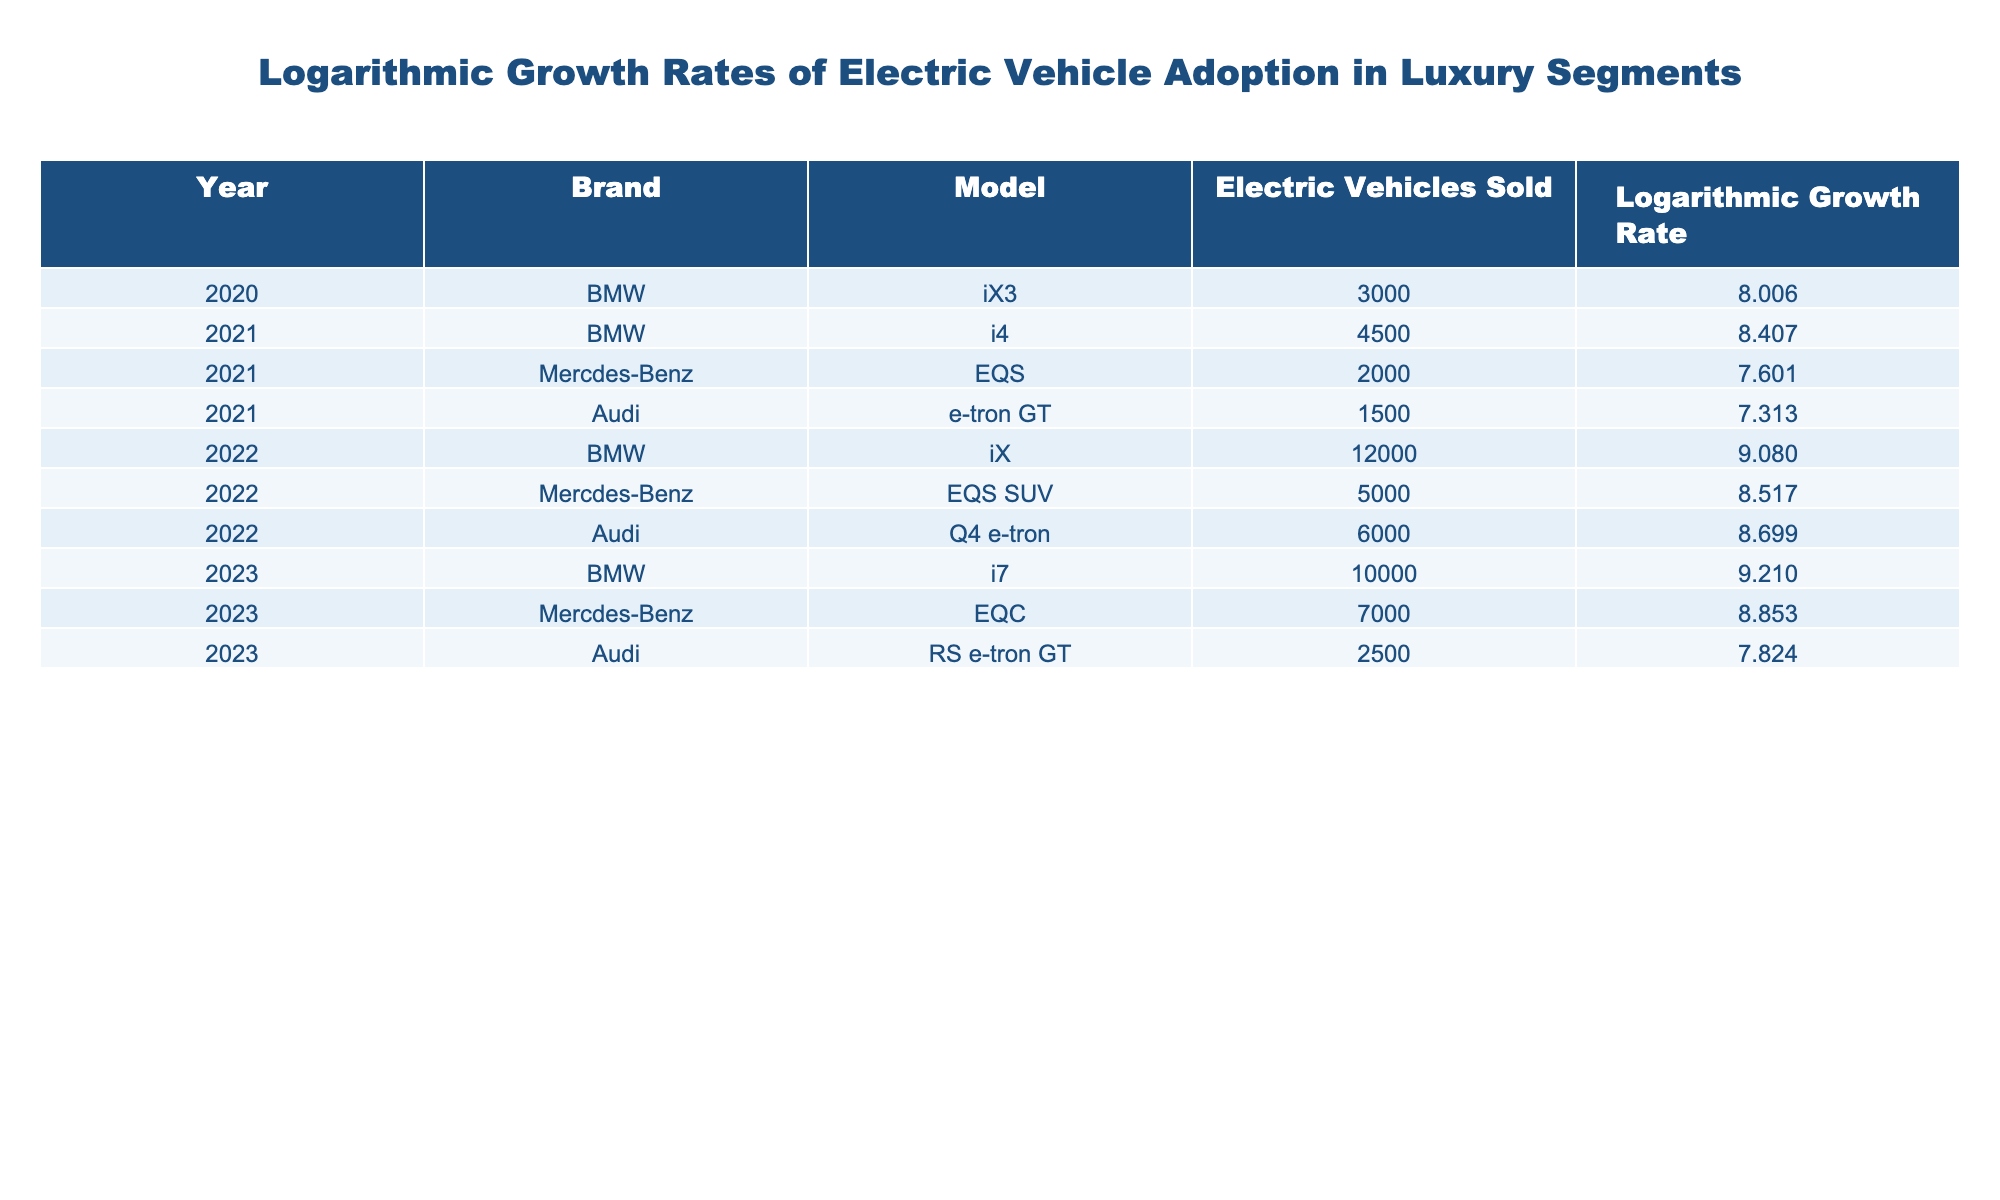What was the highest logarithmic growth rate for BMW electric vehicles in the years provided? The table shows logarithmic growth rates for each model of BMW electric vehicles. By comparing the logarithmic growth rates for the years listed (8.006 for iX3 in 2020, 8.407 for i4 in 2021, 9.080 for iX in 2022, and 9.210 for i7 in 2023), the highest rate is 9.210 for the i7 in 2023.
Answer: 9.210 Which electric vehicle model had the lowest logarithmic growth rate in 2021? The table provides growth rates for electric vehicles sold in 2021. Comparing the growth rates of the listed models (7.601 for EQS, 7.313 for e-tron GT), the lowest growth rate in that year is 7.313 for the Audi e-tron GT.
Answer: 7.313 How many electric vehicles did BMW sell in total across the years listed? To find the total number of electric vehicles sold by BMW, we add the sales figures for each model: 3000 (iX3) + 4500 (i4) + 12000 (iX) + 10000 (i7) = 3000 + 4500 + 12000 + 10000 = 29500.
Answer: 29500 Is it true that Mercedes-Benz sold more electric vehicles than Audi in 2022? In the year 2022, Mercedes-Benz sold 5000 (EQS SUV) while Audi sold 6000 (Q4 e-tron). Therefore, the statement is false, as Audi sold more vehicles than Mercedes-Benz in 2022.
Answer: No What was the percentage increase in electric vehicles sold by BMW from 2021 to 2022? In 2021, BMW sold 4500 vehicles (i4) and in 2022, it sold 12000 vehicles (iX). The increase is 12000 - 4500 = 7500. The percentage increase is (7500 / 4500) * 100 = 166.67%.
Answer: 166.67% Which brand had the highest logarithmic growth rate overall and what was that value? The table reveals the logarithmic growth rates for each brand across the listed years. On examining all the models, BMW's i7 has the highest value of 9.210, indicating that BMW had the highest growth rate among all brands.
Answer: 9.210 How many electric vehicles were sold by Mercedes-Benz across the provided years? The total electric vehicles sold by Mercedes-Benz can be computed by adding the sales from each of its models: 2000 (EQS) + 5000 (EQS SUV) + 7000 (EQC) = 2000 + 5000 + 7000 = 14000.
Answer: 14000 What model had a logarithmic growth rate over 8.5 in 2022? The models in 2022 are iX (BMW) with 9.080, EQS SUV (Mercedes-Benz) with 8.517, and Q4 e-tron (Audi) with 8.699. Therefore, the models with growth rates over 8.5 are the BMW iX, Mercedes-Benz EQS SUV, and Audi Q4 e-tron.
Answer: iX, EQS SUV, Q4 e-tron 